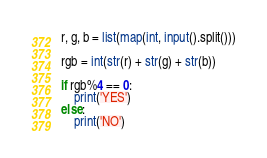Convert code to text. <code><loc_0><loc_0><loc_500><loc_500><_Python_>r, g, b = list(map(int, input().split()))

rgb = int(str(r) + str(g) + str(b))

if rgb%4 == 0:
	print('YES')
else:
	print('NO')
</code> 